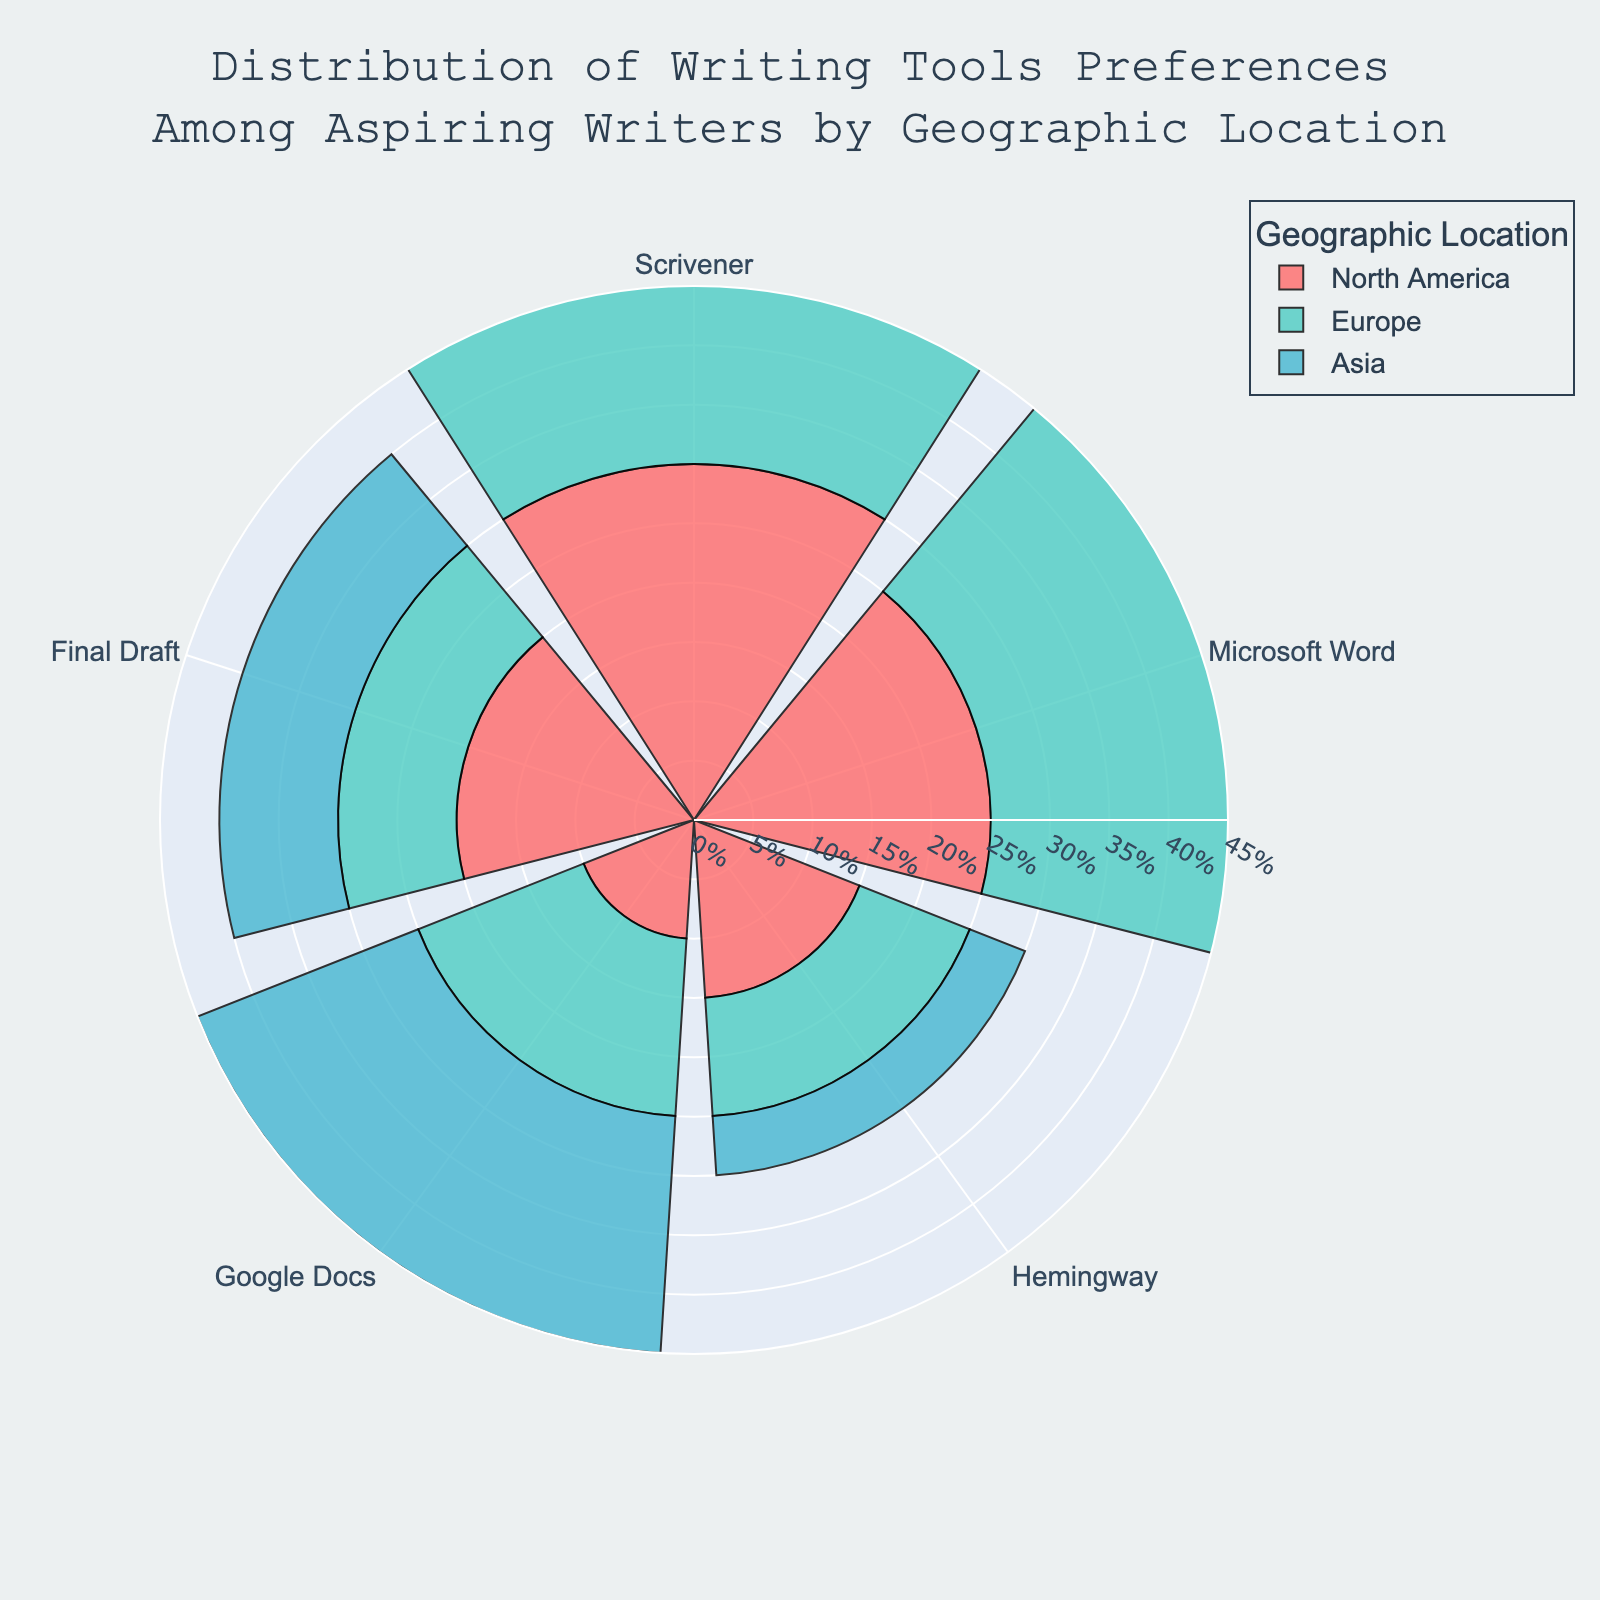What is the most preferred writing tool in North America? The figure uses colored sections to illustrate the preferences of different writing tools among aspiring writers in North America. The segment representing Scrivener is the largest, indicating it is the most preferred writing tool in North America.
Answer: Scrivener What writing tool is least preferred in Asia? The figure shows various segments for the different writing tools preferred by aspiring writers in Asia. The smallest segment, which indicates the least preferred tool, represents Hemingway.
Answer: Hemingway How do the preferences for Microsoft Word compare between North America and Europe? The segments in the rose chart represent the percentage of writers preferring Microsoft Word in different locations. Comparing North America to Europe, the North America segment is 25% while the Europe segment is 30%.
Answer: Europe has a higher preference for Microsoft Word What is the sum of the preferences for Scrivener and Final Draft in Europe? To find the total percentage, add the percentages of the segments representing Scrivener and Final Draft in Europe. Scrivener is at 35% and Final Draft is at 10%, so 35% + 10% = 45%.
Answer: 45% Which location shows the highest preference for Google Docs? Look at the segments of the rose chart for Google Docs in each geographic location. The largest segment, indicating the highest preference, is in Asia with 20%.
Answer: Asia Is there any writing tool that has the same percentage of preference in two different locations? Check the rose chart segments for any writing tools that have segments of identical sizes across two geographic locations. Final Draft is preferred equally in Europe and Asia, each with 10%.
Answer: Yes, Final Draft in Europe and Asia Which writing tool has the highest overall maximum preference when comparing all locations? Review each segment to identify the maximum percentage any writing tool reaches in any location. Scrivener in Europe reaches the highest at 35%.
Answer: Scrivener in Europe What is the difference in preference for Hemingway between North America and Asia? Compare the segments for Hemingway in North America (15%) and Asia (5%) and calculate the difference, which is 15% - 5% = 10%.
Answer: 10% What is the average preference percentage for Google Docs across all locations? Add the percentage segments for Google Docs in North America (10%), Europe (15%), and Asia (20%), which totals 45%. Then, divide by the number of locations (3): 45% / 3 = 15%.
Answer: 15% 